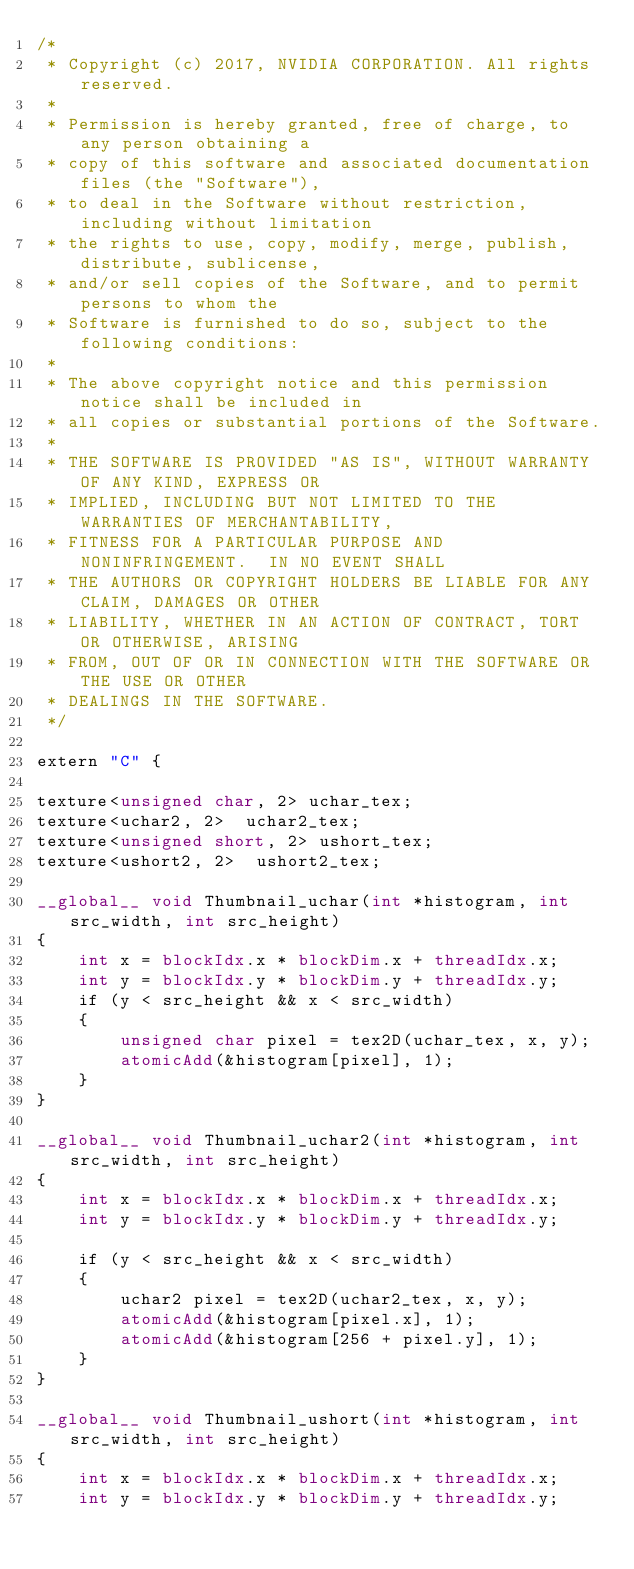Convert code to text. <code><loc_0><loc_0><loc_500><loc_500><_Cuda_>/*
 * Copyright (c) 2017, NVIDIA CORPORATION. All rights reserved.
 *
 * Permission is hereby granted, free of charge, to any person obtaining a
 * copy of this software and associated documentation files (the "Software"),
 * to deal in the Software without restriction, including without limitation
 * the rights to use, copy, modify, merge, publish, distribute, sublicense,
 * and/or sell copies of the Software, and to permit persons to whom the
 * Software is furnished to do so, subject to the following conditions:
 *
 * The above copyright notice and this permission notice shall be included in
 * all copies or substantial portions of the Software.
 *
 * THE SOFTWARE IS PROVIDED "AS IS", WITHOUT WARRANTY OF ANY KIND, EXPRESS OR
 * IMPLIED, INCLUDING BUT NOT LIMITED TO THE WARRANTIES OF MERCHANTABILITY,
 * FITNESS FOR A PARTICULAR PURPOSE AND NONINFRINGEMENT.  IN NO EVENT SHALL
 * THE AUTHORS OR COPYRIGHT HOLDERS BE LIABLE FOR ANY CLAIM, DAMAGES OR OTHER
 * LIABILITY, WHETHER IN AN ACTION OF CONTRACT, TORT OR OTHERWISE, ARISING
 * FROM, OUT OF OR IN CONNECTION WITH THE SOFTWARE OR THE USE OR OTHER
 * DEALINGS IN THE SOFTWARE.
 */

extern "C" {

texture<unsigned char, 2> uchar_tex;
texture<uchar2, 2>  uchar2_tex;
texture<unsigned short, 2> ushort_tex;
texture<ushort2, 2>  ushort2_tex;

__global__ void Thumbnail_uchar(int *histogram, int src_width, int src_height)
{
    int x = blockIdx.x * blockDim.x + threadIdx.x;
    int y = blockIdx.y * blockDim.y + threadIdx.y;
    if (y < src_height && x < src_width)
    {
        unsigned char pixel = tex2D(uchar_tex, x, y);
        atomicAdd(&histogram[pixel], 1);
    }
}

__global__ void Thumbnail_uchar2(int *histogram, int src_width, int src_height)
{
    int x = blockIdx.x * blockDim.x + threadIdx.x;
    int y = blockIdx.y * blockDim.y + threadIdx.y;

    if (y < src_height && x < src_width)
    {
        uchar2 pixel = tex2D(uchar2_tex, x, y);
        atomicAdd(&histogram[pixel.x], 1);
        atomicAdd(&histogram[256 + pixel.y], 1);
    }
}

__global__ void Thumbnail_ushort(int *histogram, int src_width, int src_height)
{
    int x = blockIdx.x * blockDim.x + threadIdx.x;
    int y = blockIdx.y * blockDim.y + threadIdx.y;
</code> 